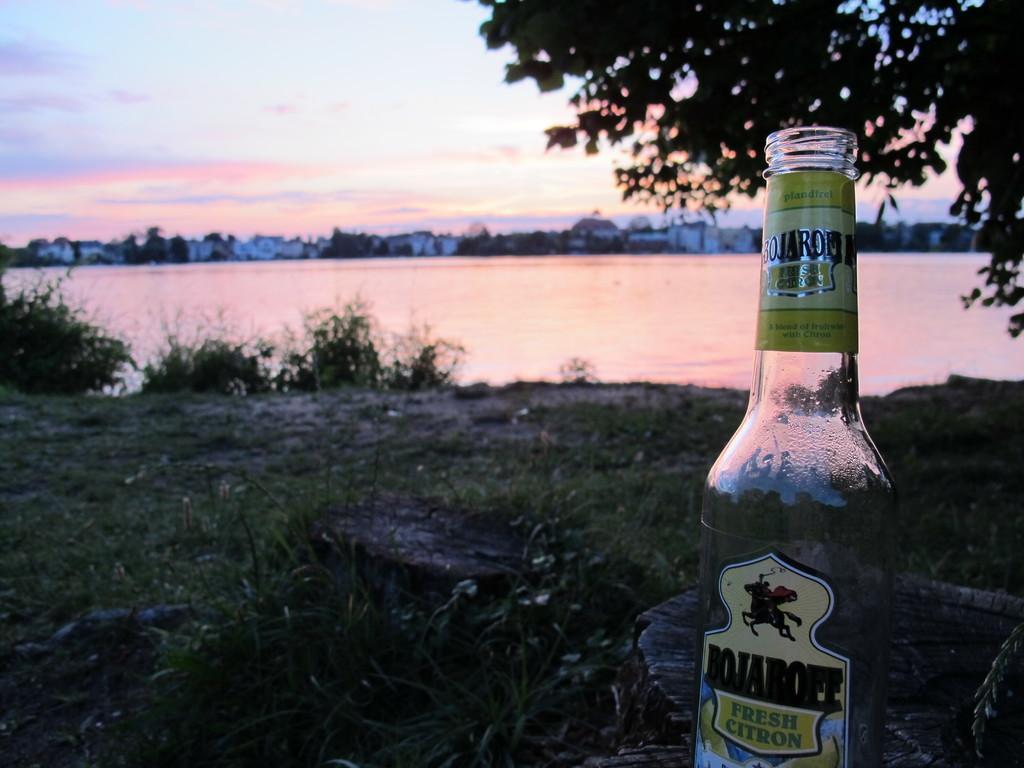Please provide a concise description of this image. In this image I can see a bottle. In the background there is a tree,water and the sky. 